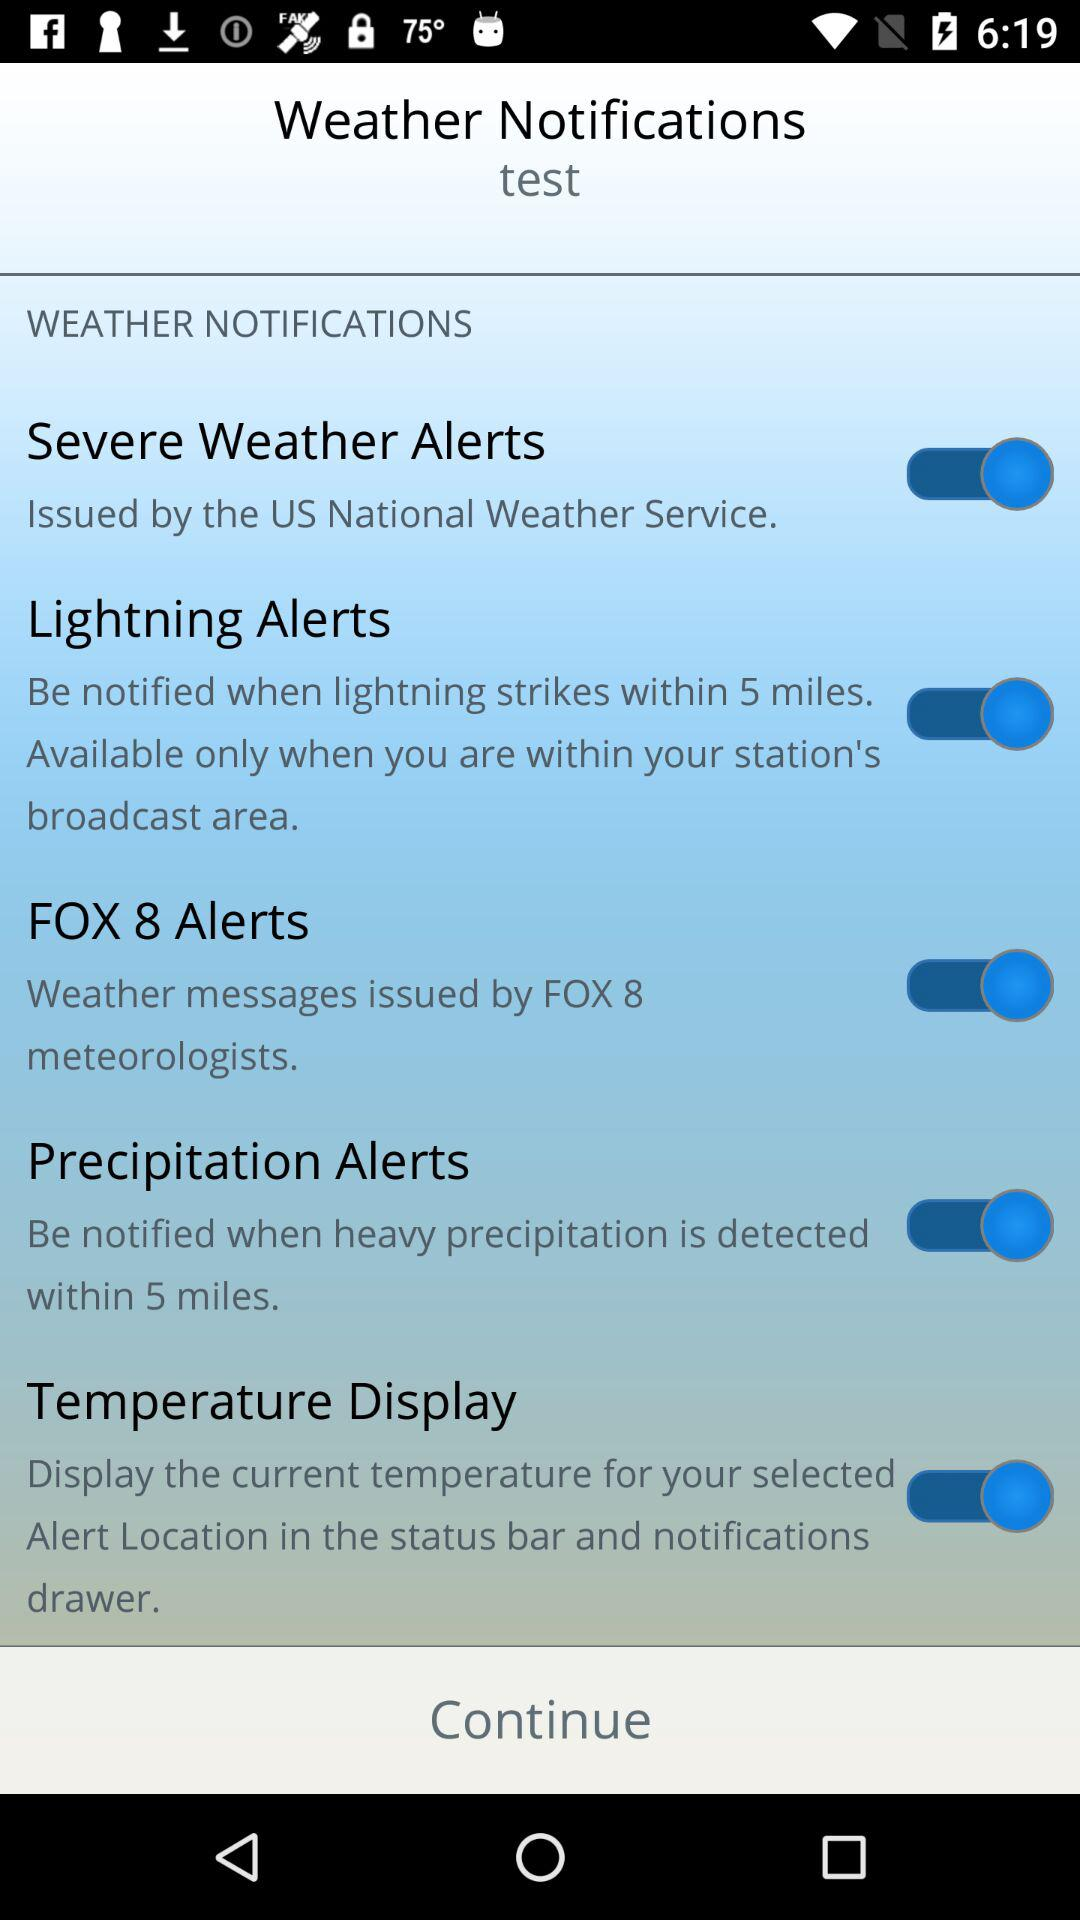By whom was the weather message issued? The weather message was issued by "FOX 8" meteorologists. 